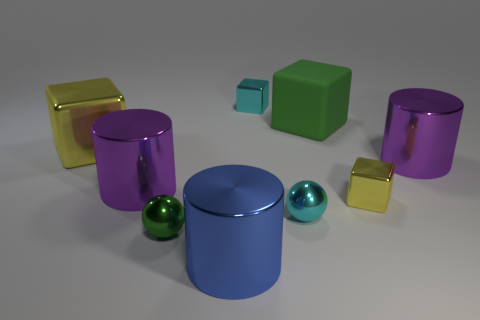Subtract all big purple metal cylinders. How many cylinders are left? 1 Add 1 big green blocks. How many objects exist? 10 Subtract all purple blocks. How many purple cylinders are left? 2 Subtract all yellow blocks. How many blocks are left? 2 Subtract all blocks. How many objects are left? 5 Add 2 large metallic cylinders. How many large metallic cylinders exist? 5 Subtract 2 purple cylinders. How many objects are left? 7 Subtract 1 blocks. How many blocks are left? 3 Subtract all green cylinders. Subtract all cyan blocks. How many cylinders are left? 3 Subtract all large things. Subtract all cyan rubber balls. How many objects are left? 4 